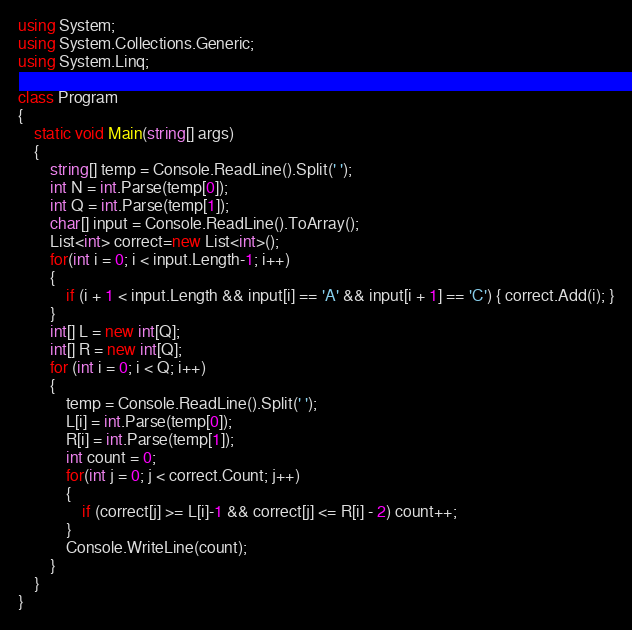Convert code to text. <code><loc_0><loc_0><loc_500><loc_500><_C#_>using System;
using System.Collections.Generic;
using System.Linq;

class Program
{
    static void Main(string[] args)
    {
        string[] temp = Console.ReadLine().Split(' ');
        int N = int.Parse(temp[0]);
        int Q = int.Parse(temp[1]);
        char[] input = Console.ReadLine().ToArray();
        List<int> correct=new List<int>();
        for(int i = 0; i < input.Length-1; i++)
        {
            if (i + 1 < input.Length && input[i] == 'A' && input[i + 1] == 'C') { correct.Add(i); }
        }
        int[] L = new int[Q];
        int[] R = new int[Q];
        for (int i = 0; i < Q; i++)
        {
            temp = Console.ReadLine().Split(' ');
            L[i] = int.Parse(temp[0]);
            R[i] = int.Parse(temp[1]);
            int count = 0;
            for(int j = 0; j < correct.Count; j++)
            {
                if (correct[j] >= L[i]-1 && correct[j] <= R[i] - 2) count++;             
            }
            Console.WriteLine(count);
        }  
    }
}
</code> 